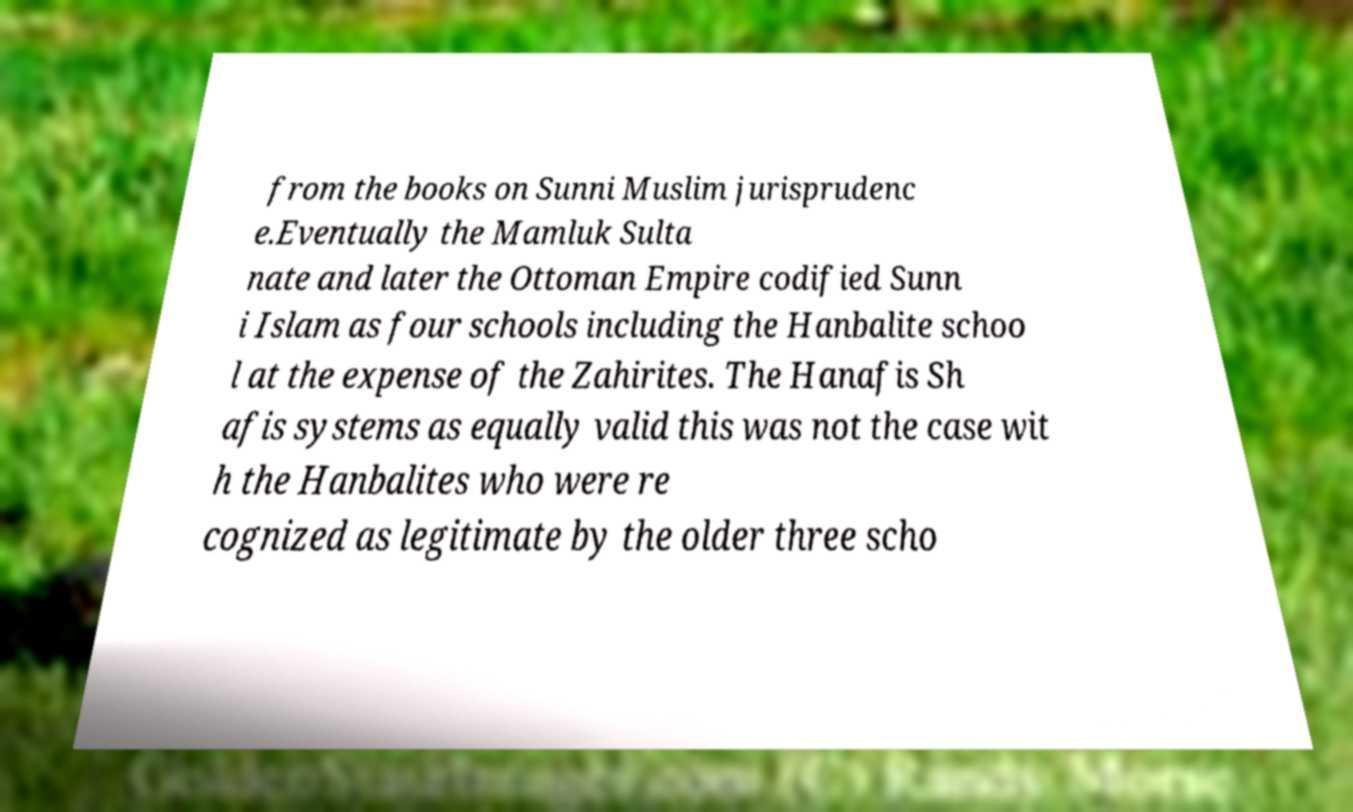What messages or text are displayed in this image? I need them in a readable, typed format. from the books on Sunni Muslim jurisprudenc e.Eventually the Mamluk Sulta nate and later the Ottoman Empire codified Sunn i Islam as four schools including the Hanbalite schoo l at the expense of the Zahirites. The Hanafis Sh afis systems as equally valid this was not the case wit h the Hanbalites who were re cognized as legitimate by the older three scho 